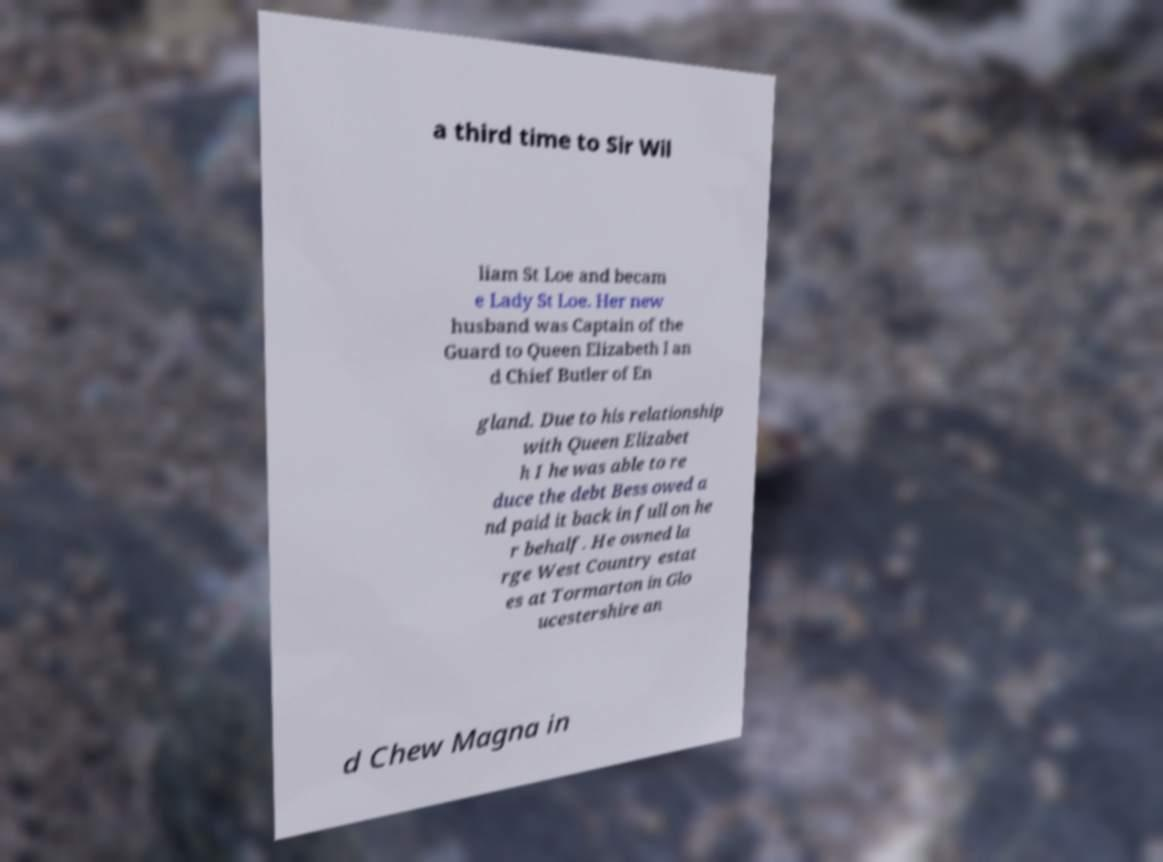For documentation purposes, I need the text within this image transcribed. Could you provide that? a third time to Sir Wil liam St Loe and becam e Lady St Loe. Her new husband was Captain of the Guard to Queen Elizabeth I an d Chief Butler of En gland. Due to his relationship with Queen Elizabet h I he was able to re duce the debt Bess owed a nd paid it back in full on he r behalf. He owned la rge West Country estat es at Tormarton in Glo ucestershire an d Chew Magna in 